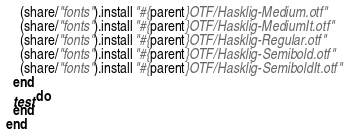Convert code to text. <code><loc_0><loc_0><loc_500><loc_500><_Ruby_>    (share/"fonts").install "#{parent}OTF/Hasklig-Medium.otf"
    (share/"fonts").install "#{parent}OTF/Hasklig-MediumIt.otf"
    (share/"fonts").install "#{parent}OTF/Hasklig-Regular.otf"
    (share/"fonts").install "#{parent}OTF/Hasklig-Semibold.otf"
    (share/"fonts").install "#{parent}OTF/Hasklig-SemiboldIt.otf"
  end
  test do
  end
end
</code> 